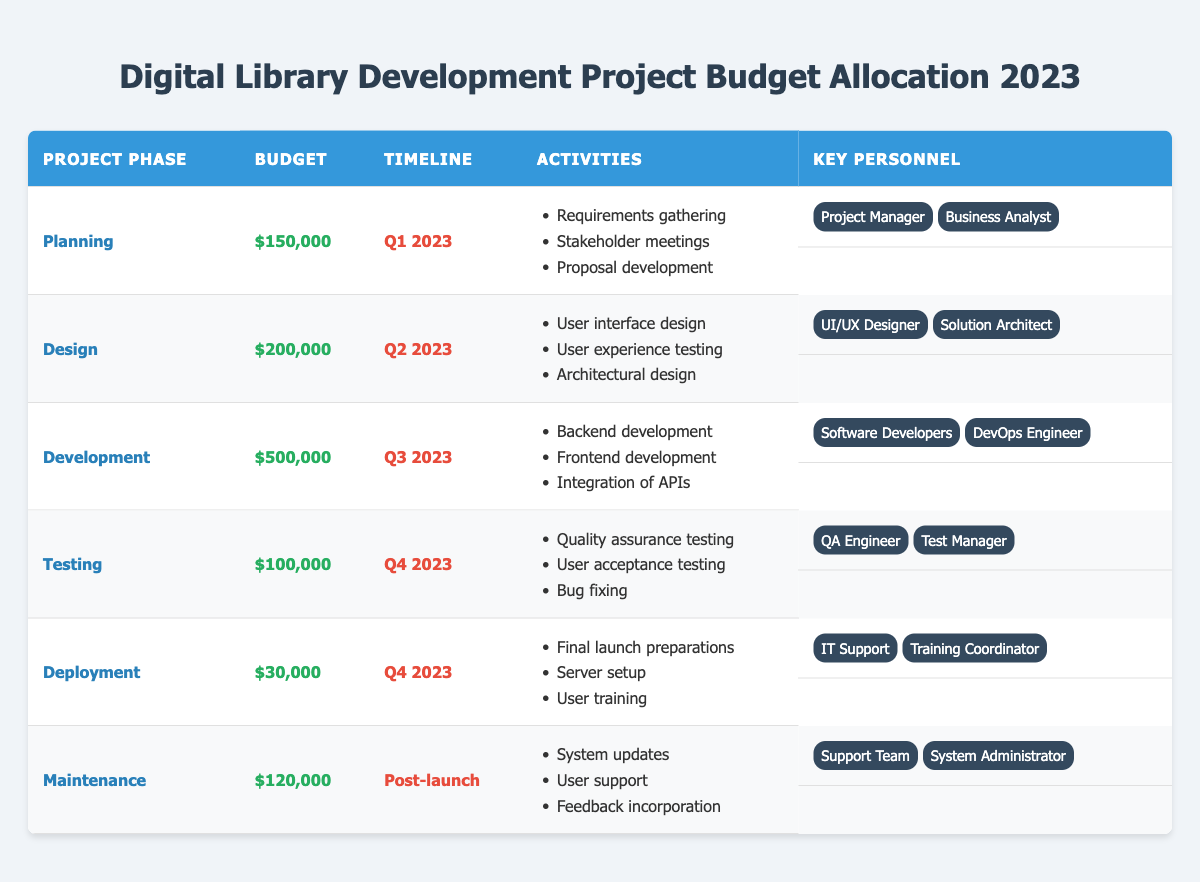What is the total budget allocated for the Development phase? The total budget allocated for the Development phase, as seen in the table, is directly listed as $500,000.
Answer: $500,000 Which phase has the highest budget allocation? By reviewing the budget figures listed in the table, the Development phase has the highest allocation of $500,000 compared to all other phases.
Answer: Development How much budget is allocated for the Testing and Deployment phases combined? The budget for Testing is $100,000 and for Deployment is $30,000. Adding these together gives $100,000 + $30,000 = $130,000.
Answer: $130,000 What is the timeline for the Design phase? The timeline for the Design phase is specified in the table as Q2 2023.
Answer: Q2 2023 Is there a specific key personnel role associated with the Maintenance phase? Yes, the key personnel for the Maintenance phase include the Support Team and the System Administrator, as shown in the table.
Answer: Yes What is the average budget allocation across all project phases? The total budget across all phases is $150,000 + $200,000 + $500,000 + $100,000 + $30,000 + $120,000 = $1,100,000. There are 6 phases, so the average is $1,100,000 / 6 = $183,333.33.
Answer: $183,333.33 In which quarter is the Deployment phase scheduled? The Deployment phase is scheduled in Q4 2023, as indicated in the table.
Answer: Q4 2023 What activities are planned for the Planning phase? The activities for the Planning phase, as listed in the table, include Requirements gathering, Stakeholder meetings, and Proposal development.
Answer: Requirements gathering, Stakeholder meetings, Proposal development Which two key personnel roles are involved in the Design phase? The table shows that the key personnel roles for the Design phase are the UI/UX Designer and the Solution Architect.
Answer: UI/UX Designer, Solution Architect If we remove the budget for Deployment, what is the new total budget for the remaining phases? The total original budget is $1,100,000 and the budget for Deployment is $30,000. Removing this gives $1,100,000 - $30,000 = $1,070,000.
Answer: $1,070,000 Are there more activities listed under the Development phase than the Testing phase? Yes, the Development phase has three activities listed (Backend development, Frontend development, Integration of APIs), while the Testing phase has three activities (Quality assurance testing, User acceptance testing, Bug fixing), making them equal. Thus, the answer is false.
Answer: False 